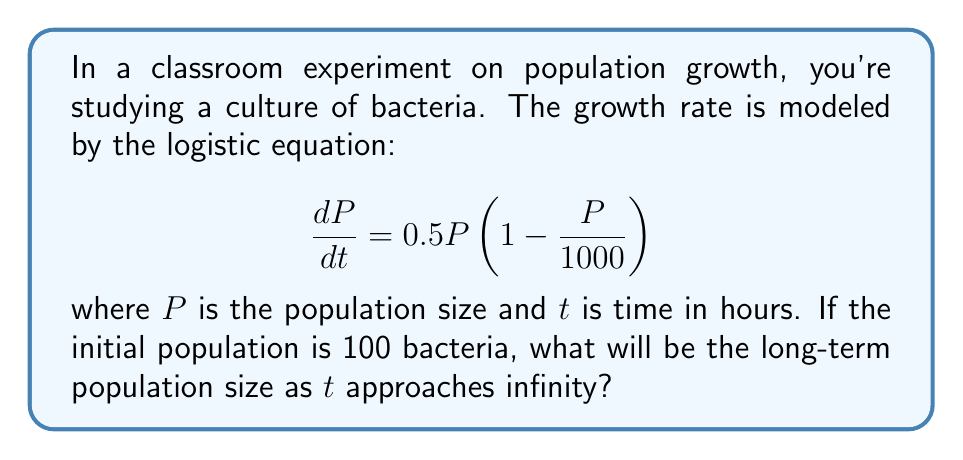Solve this math problem. To determine the long-term behavior of this logistic growth model, we need to follow these steps:

1) First, let's identify the components of the logistic equation:
   - $r = 0.5$ (intrinsic growth rate)
   - $K = 1000$ (carrying capacity)

2) In a logistic growth model, the population will always approach the carrying capacity $K$ as time approaches infinity, regardless of the initial population size (as long as it's greater than zero).

3) This is because:
   - When $P < K$, the population will grow.
   - When $P > K$, the population will decrease.
   - When $P = K$, the growth rate becomes zero:
     $$\frac{dP}{dt} = 0.5 \cdot 1000 (1 - \frac{1000}{1000}) = 0$$

4) Therefore, $P = 1000$ is a stable equilibrium point of this system.

5) We can verify this by solving for the equilibrium points:
   $$0.5P(1 - \frac{P}{1000}) = 0$$
   This equation is satisfied when $P = 0$ or $P = 1000$.

6) $P = 0$ is an unstable equilibrium (any small perturbation will lead to growth), while $P = 1000$ is stable.

Thus, as $t$ approaches infinity, the population will approach 1000 bacteria, regardless of the initial population of 100.
Answer: 1000 bacteria 